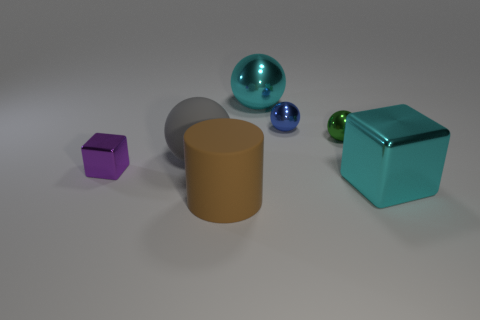Subtract all cyan balls. How many balls are left? 3 Subtract 2 cubes. How many cubes are left? 0 Add 1 big brown matte cylinders. How many objects exist? 8 Subtract all green balls. How many balls are left? 3 Subtract all blue spheres. Subtract all red blocks. How many spheres are left? 3 Subtract all yellow cylinders. Subtract all big cyan cubes. How many objects are left? 6 Add 4 big gray rubber spheres. How many big gray rubber spheres are left? 5 Add 5 cyan metallic spheres. How many cyan metallic spheres exist? 6 Subtract 0 cyan cylinders. How many objects are left? 7 Subtract all spheres. How many objects are left? 3 